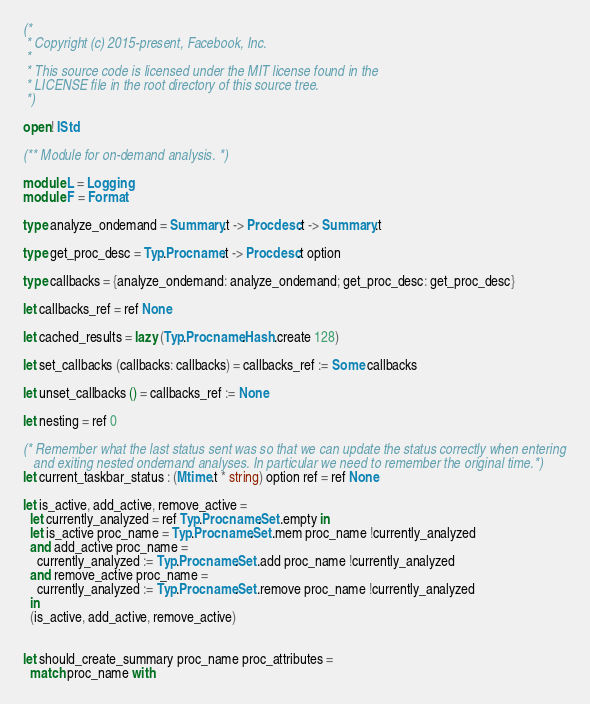Convert code to text. <code><loc_0><loc_0><loc_500><loc_500><_OCaml_>(*
 * Copyright (c) 2015-present, Facebook, Inc.
 *
 * This source code is licensed under the MIT license found in the
 * LICENSE file in the root directory of this source tree.
 *)

open! IStd

(** Module for on-demand analysis. *)

module L = Logging
module F = Format

type analyze_ondemand = Summary.t -> Procdesc.t -> Summary.t

type get_proc_desc = Typ.Procname.t -> Procdesc.t option

type callbacks = {analyze_ondemand: analyze_ondemand; get_proc_desc: get_proc_desc}

let callbacks_ref = ref None

let cached_results = lazy (Typ.Procname.Hash.create 128)

let set_callbacks (callbacks: callbacks) = callbacks_ref := Some callbacks

let unset_callbacks () = callbacks_ref := None

let nesting = ref 0

(* Remember what the last status sent was so that we can update the status correctly when entering
   and exiting nested ondemand analyses. In particular we need to remember the original time.*)
let current_taskbar_status : (Mtime.t * string) option ref = ref None

let is_active, add_active, remove_active =
  let currently_analyzed = ref Typ.Procname.Set.empty in
  let is_active proc_name = Typ.Procname.Set.mem proc_name !currently_analyzed
  and add_active proc_name =
    currently_analyzed := Typ.Procname.Set.add proc_name !currently_analyzed
  and remove_active proc_name =
    currently_analyzed := Typ.Procname.Set.remove proc_name !currently_analyzed
  in
  (is_active, add_active, remove_active)


let should_create_summary proc_name proc_attributes =
  match proc_name with</code> 